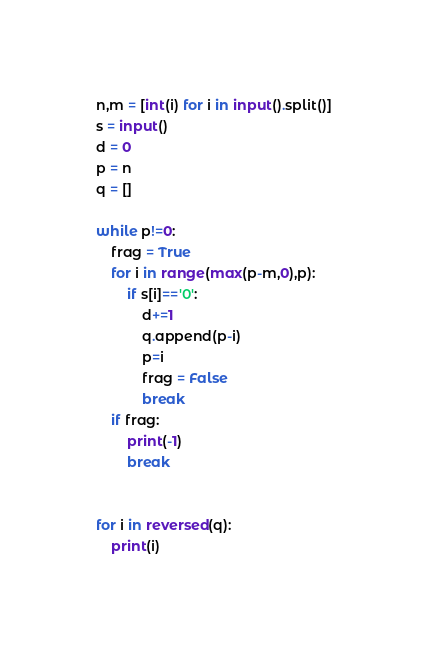<code> <loc_0><loc_0><loc_500><loc_500><_Python_>n,m = [int(i) for i in input().split()]
s = input()
d = 0
p = n
q = []

while p!=0:
    frag = True
    for i in range(max(p-m,0),p):
        if s[i]=='0':
            d+=1
            q.append(p-i)
            p=i
            frag = False
            break
    if frag:
        print(-1)
        break

        
for i in reversed(q):
    print(i)
</code> 